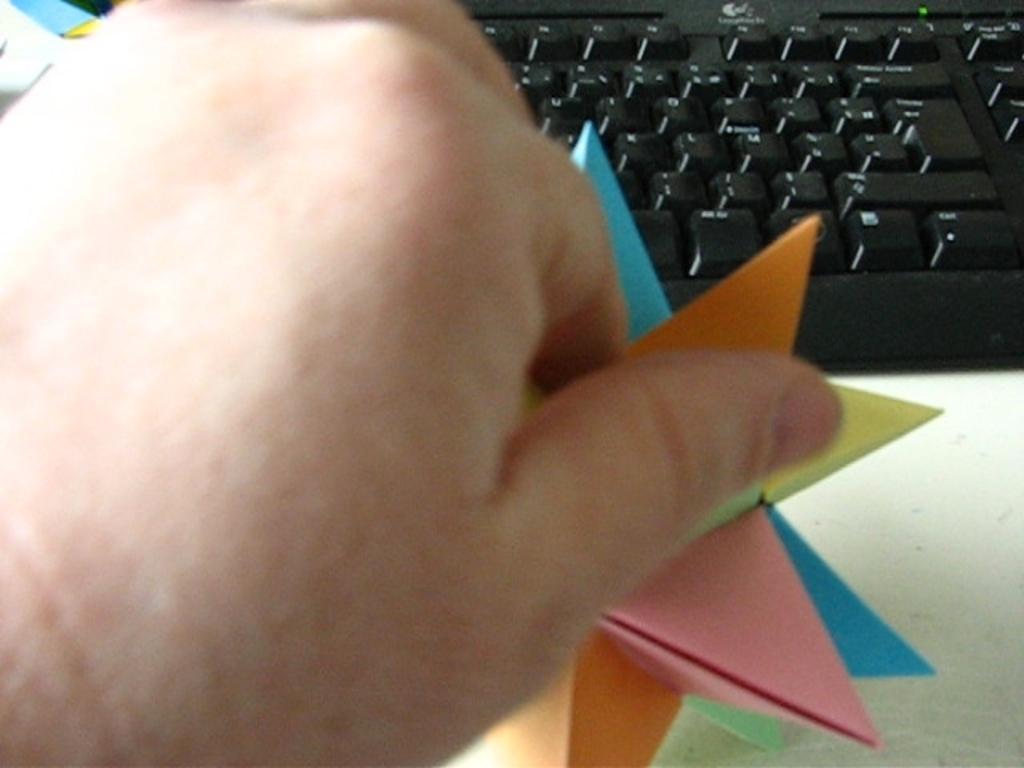Could you give a brief overview of what you see in this image? In this picture we can see a person´s hand, we can see a keyboard here, there is a paper in this hand. 